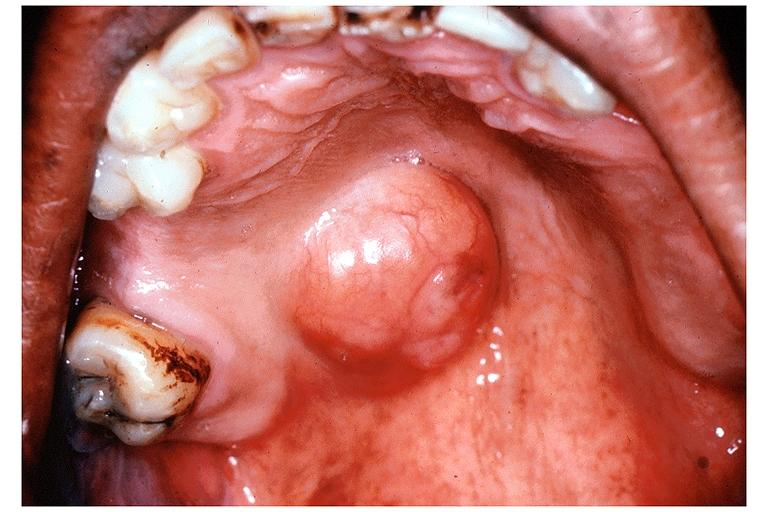s oral present?
Answer the question using a single word or phrase. Yes 